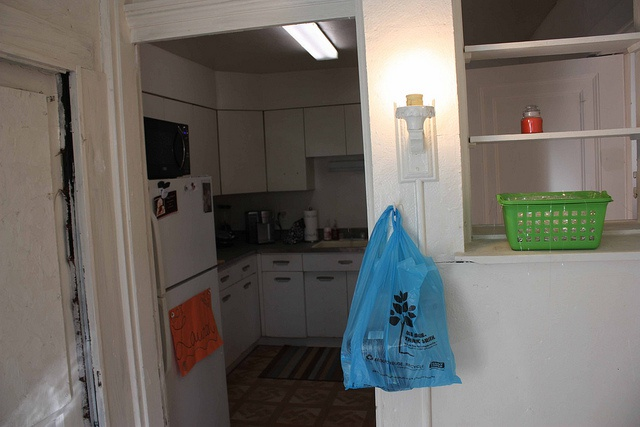Describe the objects in this image and their specific colors. I can see refrigerator in gray, maroon, and black tones, microwave in gray, black, and darkblue tones, sink in black and gray tones, bottle in gray and maroon tones, and bottle in gray and black tones in this image. 